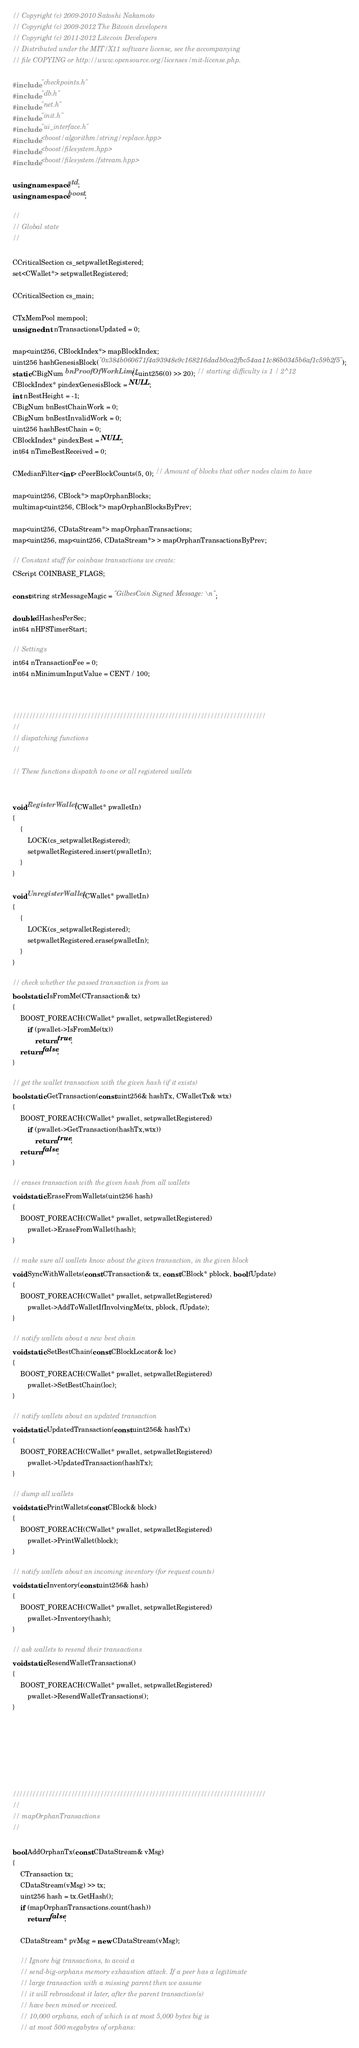Convert code to text. <code><loc_0><loc_0><loc_500><loc_500><_C++_>// Copyright (c) 2009-2010 Satoshi Nakamoto
// Copyright (c) 2009-2012 The Bitcoin developers
// Copyright (c) 2011-2012 Litecoin Developers
// Distributed under the MIT/X11 software license, see the accompanying
// file COPYING or http://www.opensource.org/licenses/mit-license.php.

#include "checkpoints.h"
#include "db.h"
#include "net.h"
#include "init.h"
#include "ui_interface.h"
#include <boost/algorithm/string/replace.hpp>
#include <boost/filesystem.hpp>
#include <boost/filesystem/fstream.hpp>

using namespace std;
using namespace boost;

//
// Global state
//

CCriticalSection cs_setpwalletRegistered;
set<CWallet*> setpwalletRegistered;

CCriticalSection cs_main;

CTxMemPool mempool;
unsigned int nTransactionsUpdated = 0;

map<uint256, CBlockIndex*> mapBlockIndex;
uint256 hashGenesisBlock("0x384b060671f4a93948e9c168216dadb0ca2fbc54aa11c86b0345b6af1c59b2f5");
static CBigNum bnProofOfWorkLimit(~uint256(0) >> 20); // starting difficulty is 1 / 2^12
CBlockIndex* pindexGenesisBlock = NULL;
int nBestHeight = -1;
CBigNum bnBestChainWork = 0;
CBigNum bnBestInvalidWork = 0;
uint256 hashBestChain = 0;
CBlockIndex* pindexBest = NULL;
int64 nTimeBestReceived = 0;

CMedianFilter<int> cPeerBlockCounts(5, 0); // Amount of blocks that other nodes claim to have

map<uint256, CBlock*> mapOrphanBlocks;
multimap<uint256, CBlock*> mapOrphanBlocksByPrev;

map<uint256, CDataStream*> mapOrphanTransactions;
map<uint256, map<uint256, CDataStream*> > mapOrphanTransactionsByPrev;

// Constant stuff for coinbase transactions we create:
CScript COINBASE_FLAGS;

const string strMessageMagic = "GilbesCoin Signed Message:\n";

double dHashesPerSec;
int64 nHPSTimerStart;

// Settings
int64 nTransactionFee = 0;
int64 nMinimumInputValue = CENT / 100;



//////////////////////////////////////////////////////////////////////////////
//
// dispatching functions
//

// These functions dispatch to one or all registered wallets


void RegisterWallet(CWallet* pwalletIn)
{
    {
        LOCK(cs_setpwalletRegistered);
        setpwalletRegistered.insert(pwalletIn);
    }
}

void UnregisterWallet(CWallet* pwalletIn)
{
    {
        LOCK(cs_setpwalletRegistered);
        setpwalletRegistered.erase(pwalletIn);
    }
}

// check whether the passed transaction is from us
bool static IsFromMe(CTransaction& tx)
{
    BOOST_FOREACH(CWallet* pwallet, setpwalletRegistered)
        if (pwallet->IsFromMe(tx))
            return true;
    return false;
}

// get the wallet transaction with the given hash (if it exists)
bool static GetTransaction(const uint256& hashTx, CWalletTx& wtx)
{
    BOOST_FOREACH(CWallet* pwallet, setpwalletRegistered)
        if (pwallet->GetTransaction(hashTx,wtx))
            return true;
    return false;
}

// erases transaction with the given hash from all wallets
void static EraseFromWallets(uint256 hash)
{
    BOOST_FOREACH(CWallet* pwallet, setpwalletRegistered)
        pwallet->EraseFromWallet(hash);
}

// make sure all wallets know about the given transaction, in the given block
void SyncWithWallets(const CTransaction& tx, const CBlock* pblock, bool fUpdate)
{
    BOOST_FOREACH(CWallet* pwallet, setpwalletRegistered)
        pwallet->AddToWalletIfInvolvingMe(tx, pblock, fUpdate);
}

// notify wallets about a new best chain
void static SetBestChain(const CBlockLocator& loc)
{
    BOOST_FOREACH(CWallet* pwallet, setpwalletRegistered)
        pwallet->SetBestChain(loc);
}

// notify wallets about an updated transaction
void static UpdatedTransaction(const uint256& hashTx)
{
    BOOST_FOREACH(CWallet* pwallet, setpwalletRegistered)
        pwallet->UpdatedTransaction(hashTx);
}

// dump all wallets
void static PrintWallets(const CBlock& block)
{
    BOOST_FOREACH(CWallet* pwallet, setpwalletRegistered)
        pwallet->PrintWallet(block);
}

// notify wallets about an incoming inventory (for request counts)
void static Inventory(const uint256& hash)
{
    BOOST_FOREACH(CWallet* pwallet, setpwalletRegistered)
        pwallet->Inventory(hash);
}

// ask wallets to resend their transactions
void static ResendWalletTransactions()
{
    BOOST_FOREACH(CWallet* pwallet, setpwalletRegistered)
        pwallet->ResendWalletTransactions();
}







//////////////////////////////////////////////////////////////////////////////
//
// mapOrphanTransactions
//

bool AddOrphanTx(const CDataStream& vMsg)
{
    CTransaction tx;
    CDataStream(vMsg) >> tx;
    uint256 hash = tx.GetHash();
    if (mapOrphanTransactions.count(hash))
        return false;

    CDataStream* pvMsg = new CDataStream(vMsg);

    // Ignore big transactions, to avoid a
    // send-big-orphans memory exhaustion attack. If a peer has a legitimate
    // large transaction with a missing parent then we assume
    // it will rebroadcast it later, after the parent transaction(s)
    // have been mined or received.
    // 10,000 orphans, each of which is at most 5,000 bytes big is
    // at most 500 megabytes of orphans:</code> 